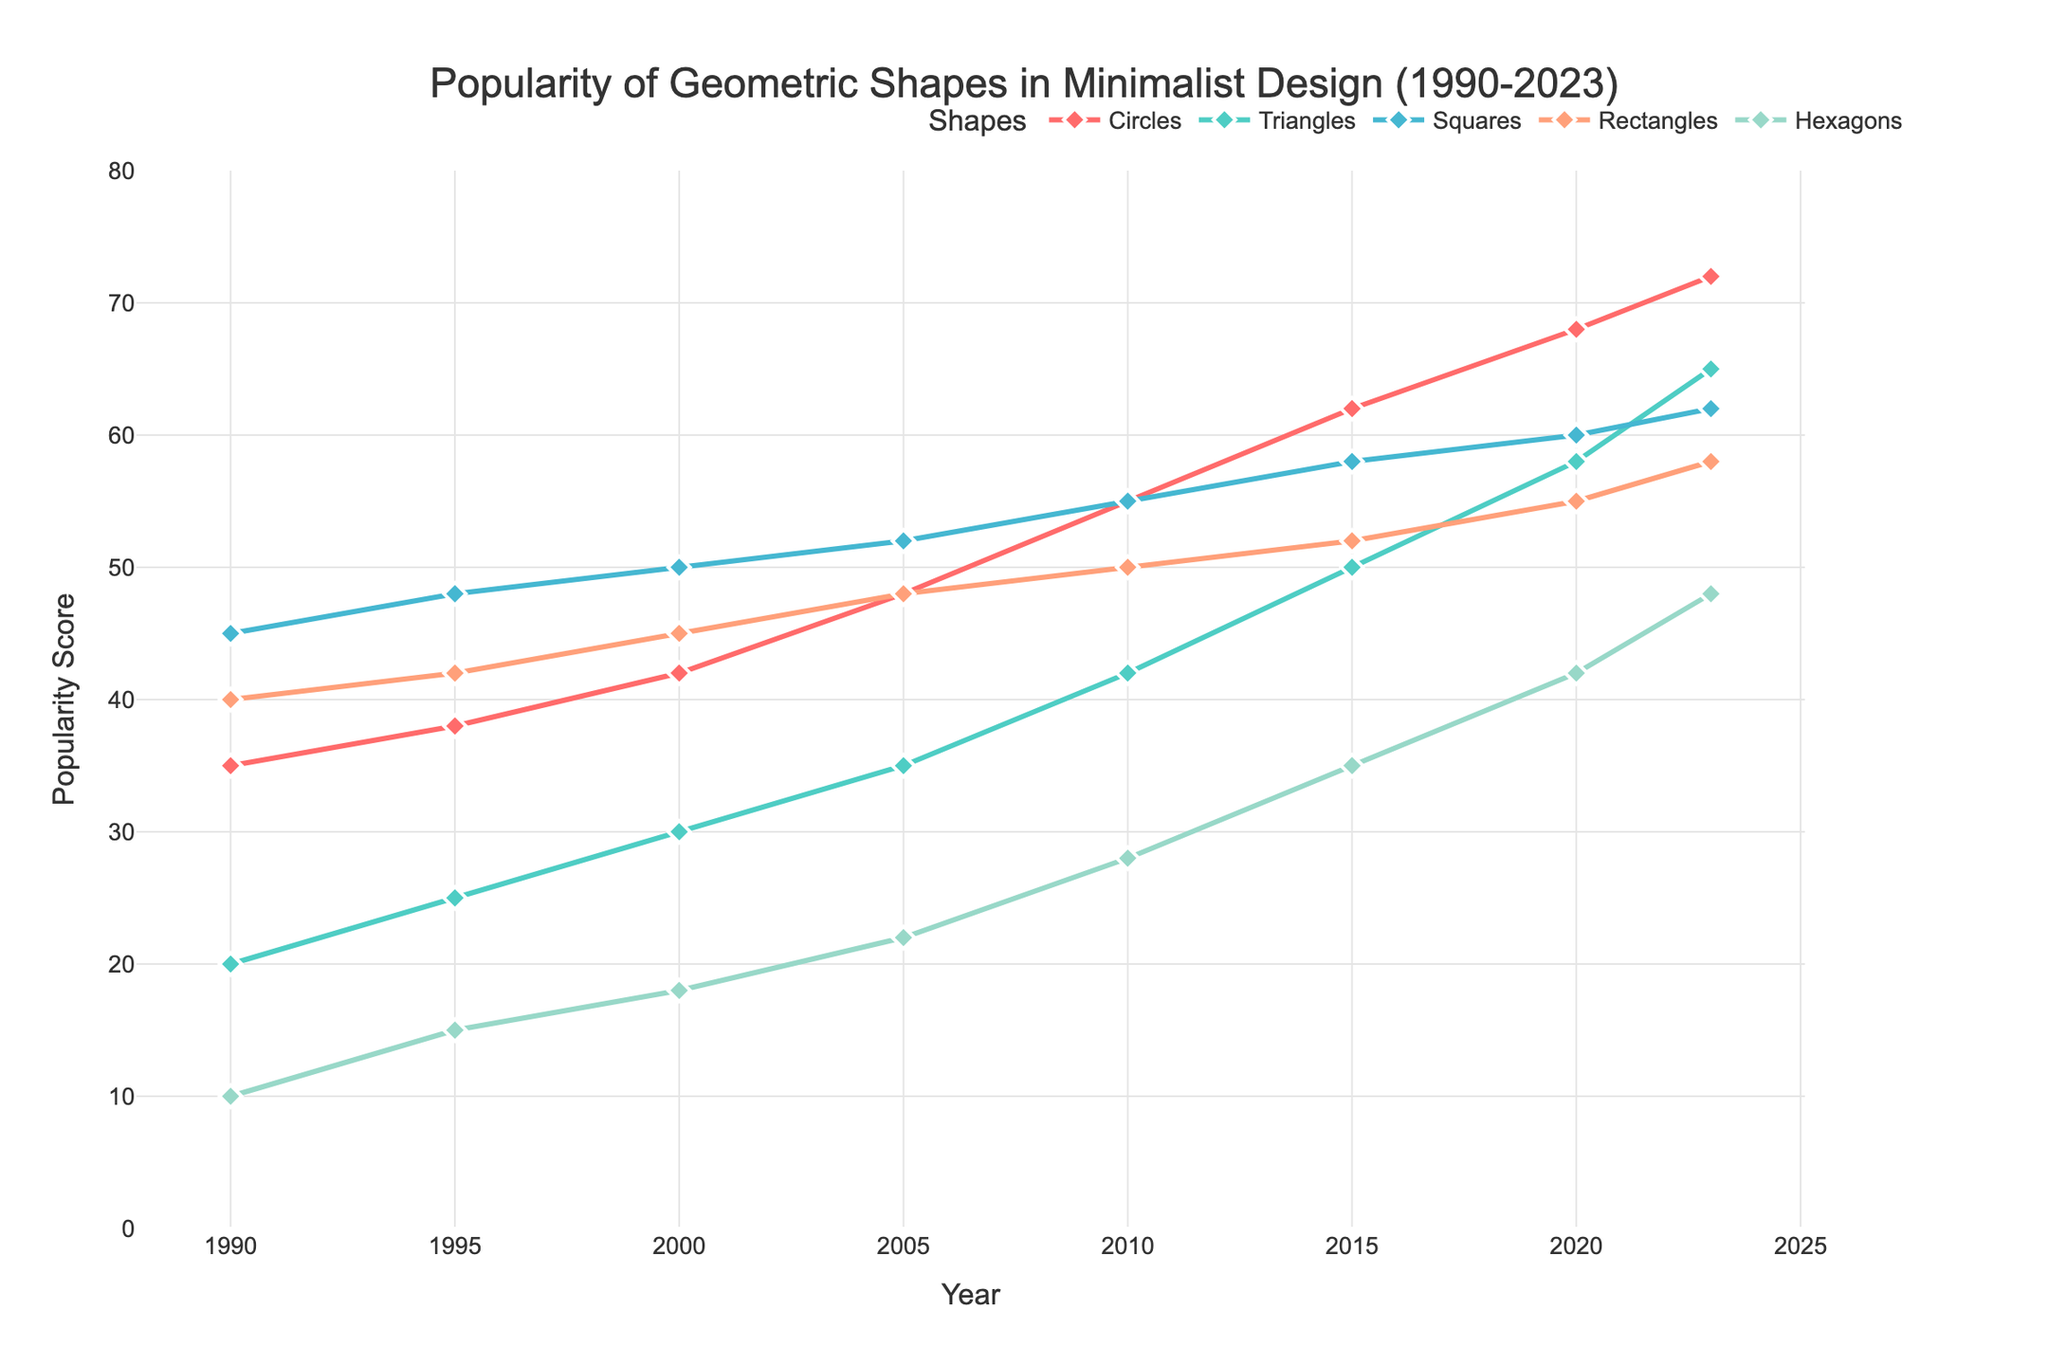What's the most popular geometric shape in 2023? Look at the 2023 data points, the highest line visually is for Circles at 72.
Answer: Circles Which shape had the largest increase in popularity from 1990 to 2023? Compare the values from 1990 and 2023 for all shapes: Circles (72-35=37), Triangles (65-20=45), Squares (62-45=17), Rectangles (58-40=18), Hexagons (48-10=38). Triangles had the largest difference.
Answer: Triangles In what year did Squares become less popular than Circles? Compare the lines visually: Squares and Circles intersect between 1995 and 2000 but after 2000, Circles are always above Squares.
Answer: 2000 Compare the popularity of Rectangles and Hexagons in 2000. Which is more popular, and by how much? In 2000, Rectangles have a value of 45 and Hexagons have a value of 18. The difference is 45 - 18.
Answer: Rectangles, 27 What is the average popularity score of Hexagons from 1990 to 2023? Add the values of Hexagons (10+15+18+22+28+35+42+48) = 218 and divide by 8 (years).
Answer: 27.25 What was the popularity score of Circles in 2010, and how does it compare to that of Triangles in the same year? In 2010, Circles have a value of 55 and Triangles have a value of 42. Circles are more popular by 55 - 42.
Answer: 13 Which shape had the least increase in popularity from 2000 to 2020? Calculate the differences for all shapes from 2000 to 2020: Circles (68-42=26), Triangles (58-30=28), Squares (60-50=10), Rectangles (55-45=10), Hexagons (42-18=24). The shapes with the least increase are Squares and Rectangles (both 10).
Answer: Squares, Rectangles Between 2005 and 2015, what was the change in popularity of Squares? In 2005, Squares had a value of 52, and in 2015 they had a value of 58. The difference is 58 - 52.
Answer: 6 How many different shapes experienced a decline in popularity between 1995 and 2000? By checking the data points between 1995 and 2000, we see no shape having a decrease in their scores.
Answer: 0 In which year was the popularity of Rectangles and Squares equal? Find the year where their values match: No year has equal values directly, but the closest point is 2010 (Rectangles 50, Squares 55).
Answer: Never 